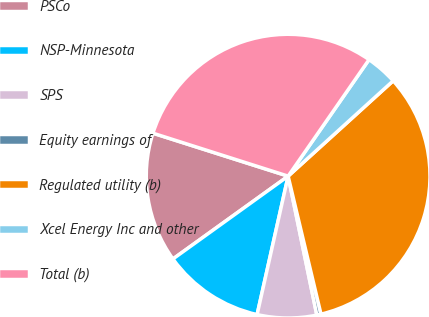Convert chart. <chart><loc_0><loc_0><loc_500><loc_500><pie_chart><fcel>PSCo<fcel>NSP-Minnesota<fcel>SPS<fcel>Equity earnings of<fcel>Regulated utility (b)<fcel>Xcel Energy Inc and other<fcel>Total (b)<nl><fcel>14.82%<fcel>11.57%<fcel>6.75%<fcel>0.48%<fcel>33.01%<fcel>3.61%<fcel>29.76%<nl></chart> 